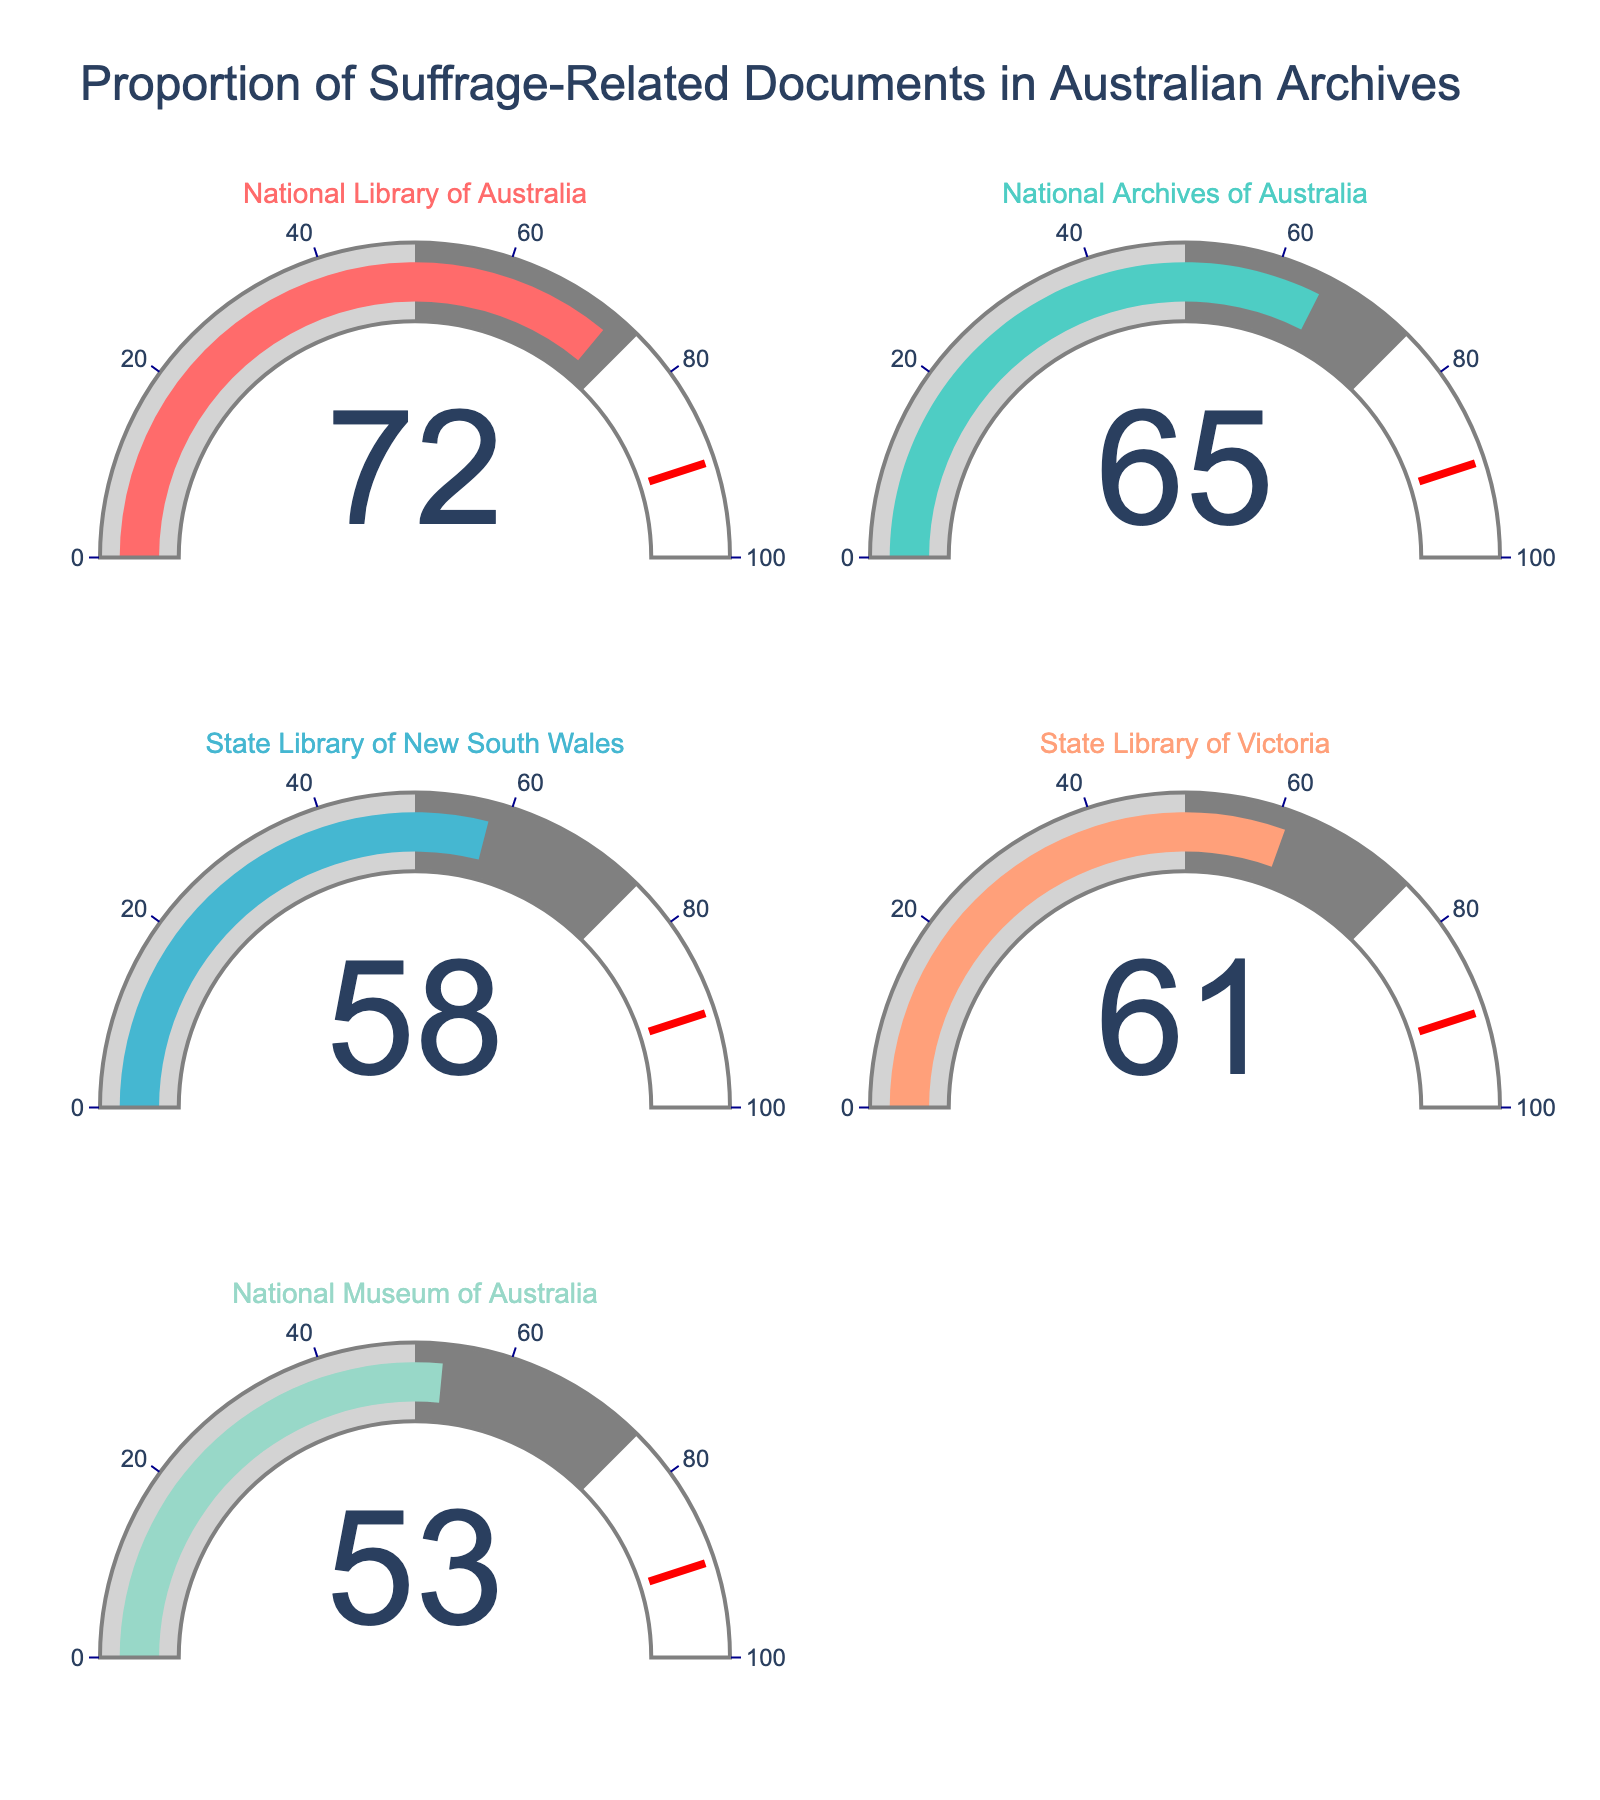What's the title of the figure? The title is located at the top center of the figure and reads "Proportion of Suffrage-Related Documents in Australian Archives".
Answer: Proportion of Suffrage-Related Documents in Australian Archives How many gauge charts are present in the figure? The figure consists of 5 gauge charts arranged in a 3x2 grid with one empty subplot.
Answer: 5 Which library has the highest proportion of suffrage-related documents? The National Library of Australia gauge shows the highest proportion with a value of 72.
Answer: National Library of Australia Which institution has a proportion of suffrage-related documents that is closest to 50%? The National Museum of Australia has a gauge showing the closest value to 50, which is 53.
Answer: National Museum of Australia What is the percentage difference between the institution with the highest and the lowest proportion of suffrage-related documents? The highest percentage is 72 (National Library of Australia) and the lowest is 53 (National Museum of Australia). The difference is 72 - 53 = 19.
Answer: 19 What's the average percentage of suffrage-related documents across all institutions shown? Add the percentages: 72 (NLA) + 65 (NAA) + 58 (SLNSW) + 61 (SLV) + 53 (NMA) = 309. Then divide by 5: 309 / 5 = 61.8.
Answer: 61.8 Which two institutions have the closest percentages of suffrage-related documents? The State Library of Victoria has 61% and the National Archives of Australia has 65%, making their difference 65 - 61 = 4, which is the smallest difference among all pairs.
Answer: State Library of Victoria and National Archives of Australia Is there a threshold indicator on each gauge, and if so, what value does it represent? Each gauge has a red threshold line, which represents a value of 90, indicating a significant threshold for the proportion.
Answer: 90 Is there any institution that falls below 60% in the proportion of suffrage-related documents? The National Museum of Australia (53%) and the State Library of New South Wales (58%) are below the 60% threshold.
Answer: Yes In how many colors are the gauge bars represented, and what can be inferred from the chosen colors? There are 5 different colors used for the gauge bars, indicating distinct proportions for each institution, aiding easy differentiation.
Answer: 5 colors 